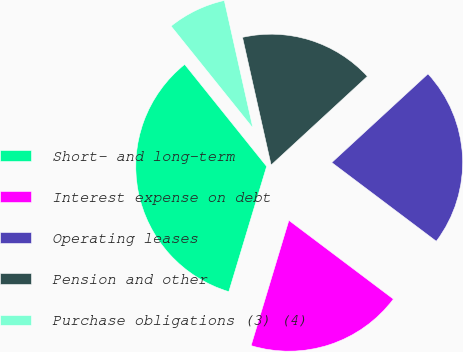Convert chart to OTSL. <chart><loc_0><loc_0><loc_500><loc_500><pie_chart><fcel>Short- and long-term<fcel>Interest expense on debt<fcel>Operating leases<fcel>Pension and other<fcel>Purchase obligations (3) (4)<nl><fcel>34.56%<fcel>19.39%<fcel>22.12%<fcel>16.66%<fcel>7.26%<nl></chart> 